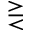Convert formula to latex. <formula><loc_0><loc_0><loc_500><loc_500>> r e q l e s s</formula> 